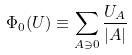Convert formula to latex. <formula><loc_0><loc_0><loc_500><loc_500>\Phi _ { 0 } ( U ) \equiv \sum _ { A \ni 0 } \frac { U _ { A } } { | A | }</formula> 